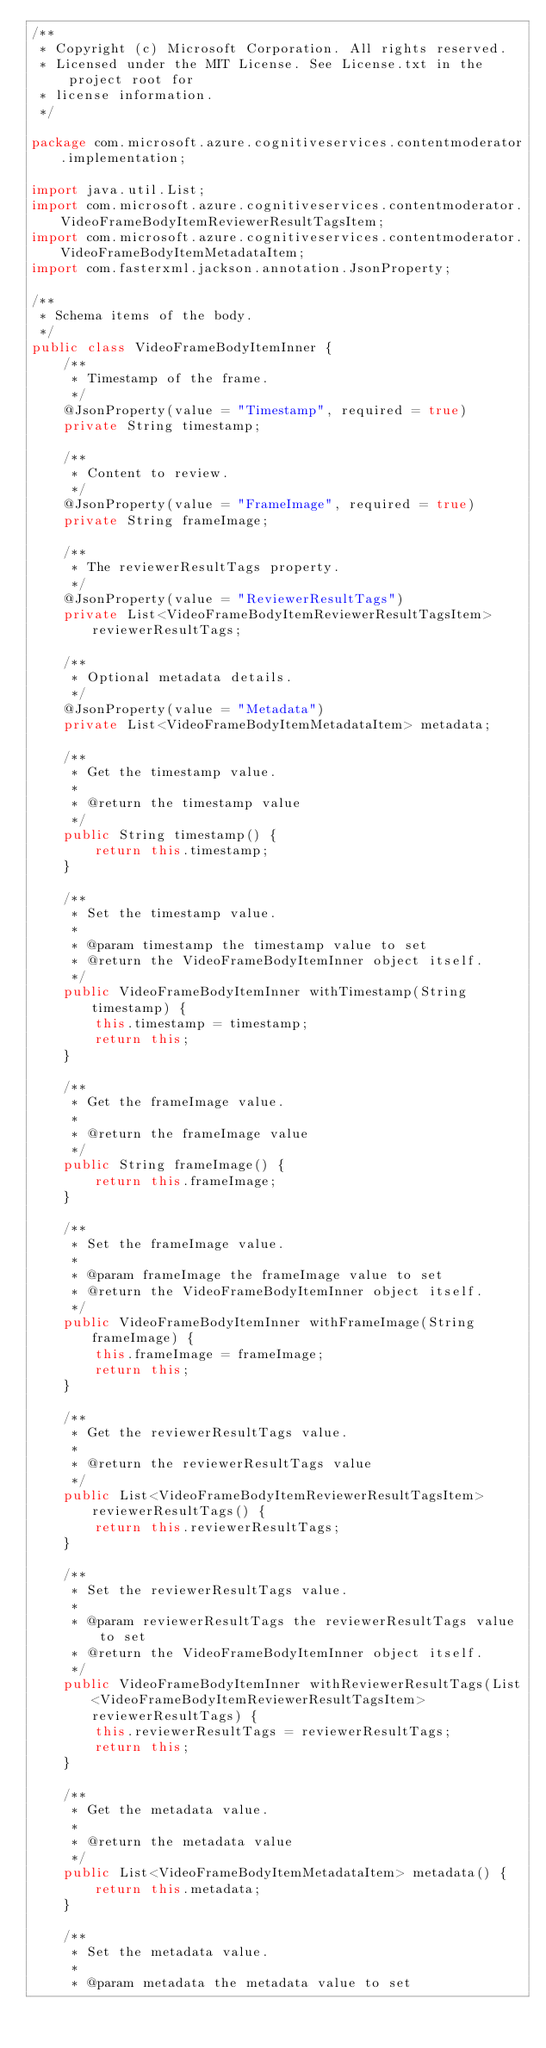Convert code to text. <code><loc_0><loc_0><loc_500><loc_500><_Java_>/**
 * Copyright (c) Microsoft Corporation. All rights reserved.
 * Licensed under the MIT License. See License.txt in the project root for
 * license information.
 */

package com.microsoft.azure.cognitiveservices.contentmoderator.implementation;

import java.util.List;
import com.microsoft.azure.cognitiveservices.contentmoderator.VideoFrameBodyItemReviewerResultTagsItem;
import com.microsoft.azure.cognitiveservices.contentmoderator.VideoFrameBodyItemMetadataItem;
import com.fasterxml.jackson.annotation.JsonProperty;

/**
 * Schema items of the body.
 */
public class VideoFrameBodyItemInner {
    /**
     * Timestamp of the frame.
     */
    @JsonProperty(value = "Timestamp", required = true)
    private String timestamp;

    /**
     * Content to review.
     */
    @JsonProperty(value = "FrameImage", required = true)
    private String frameImage;

    /**
     * The reviewerResultTags property.
     */
    @JsonProperty(value = "ReviewerResultTags")
    private List<VideoFrameBodyItemReviewerResultTagsItem> reviewerResultTags;

    /**
     * Optional metadata details.
     */
    @JsonProperty(value = "Metadata")
    private List<VideoFrameBodyItemMetadataItem> metadata;

    /**
     * Get the timestamp value.
     *
     * @return the timestamp value
     */
    public String timestamp() {
        return this.timestamp;
    }

    /**
     * Set the timestamp value.
     *
     * @param timestamp the timestamp value to set
     * @return the VideoFrameBodyItemInner object itself.
     */
    public VideoFrameBodyItemInner withTimestamp(String timestamp) {
        this.timestamp = timestamp;
        return this;
    }

    /**
     * Get the frameImage value.
     *
     * @return the frameImage value
     */
    public String frameImage() {
        return this.frameImage;
    }

    /**
     * Set the frameImage value.
     *
     * @param frameImage the frameImage value to set
     * @return the VideoFrameBodyItemInner object itself.
     */
    public VideoFrameBodyItemInner withFrameImage(String frameImage) {
        this.frameImage = frameImage;
        return this;
    }

    /**
     * Get the reviewerResultTags value.
     *
     * @return the reviewerResultTags value
     */
    public List<VideoFrameBodyItemReviewerResultTagsItem> reviewerResultTags() {
        return this.reviewerResultTags;
    }

    /**
     * Set the reviewerResultTags value.
     *
     * @param reviewerResultTags the reviewerResultTags value to set
     * @return the VideoFrameBodyItemInner object itself.
     */
    public VideoFrameBodyItemInner withReviewerResultTags(List<VideoFrameBodyItemReviewerResultTagsItem> reviewerResultTags) {
        this.reviewerResultTags = reviewerResultTags;
        return this;
    }

    /**
     * Get the metadata value.
     *
     * @return the metadata value
     */
    public List<VideoFrameBodyItemMetadataItem> metadata() {
        return this.metadata;
    }

    /**
     * Set the metadata value.
     *
     * @param metadata the metadata value to set</code> 